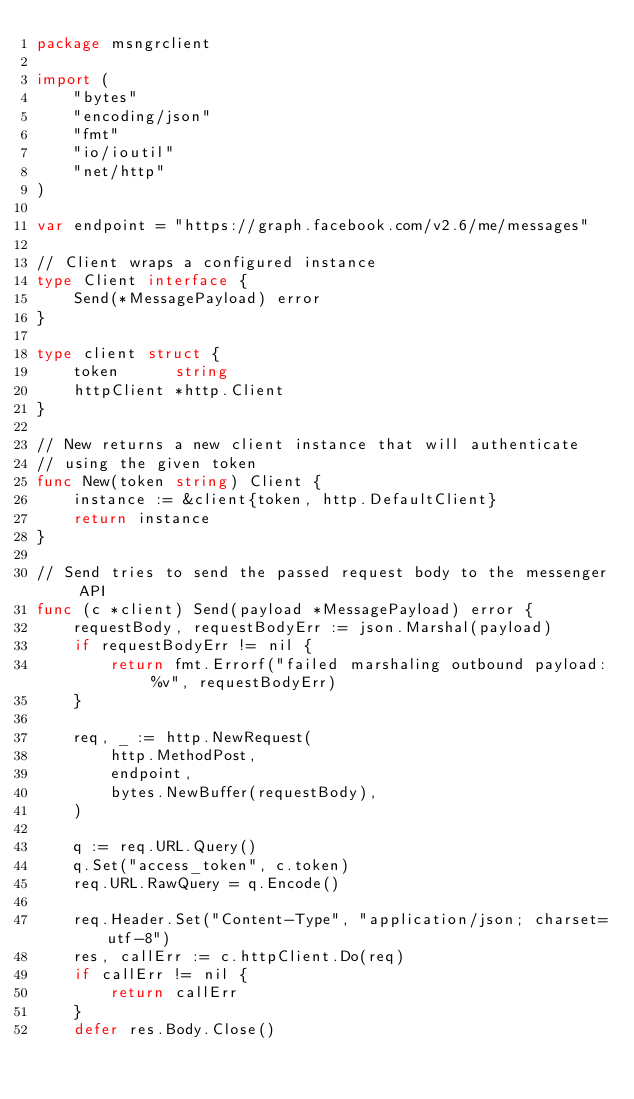<code> <loc_0><loc_0><loc_500><loc_500><_Go_>package msngrclient

import (
	"bytes"
	"encoding/json"
	"fmt"
	"io/ioutil"
	"net/http"
)

var endpoint = "https://graph.facebook.com/v2.6/me/messages"

// Client wraps a configured instance
type Client interface {
	Send(*MessagePayload) error
}

type client struct {
	token      string
	httpClient *http.Client
}

// New returns a new client instance that will authenticate
// using the given token
func New(token string) Client {
	instance := &client{token, http.DefaultClient}
	return instance
}

// Send tries to send the passed request body to the messenger API
func (c *client) Send(payload *MessagePayload) error {
	requestBody, requestBodyErr := json.Marshal(payload)
	if requestBodyErr != nil {
		return fmt.Errorf("failed marshaling outbound payload: %v", requestBodyErr)
	}

	req, _ := http.NewRequest(
		http.MethodPost,
		endpoint,
		bytes.NewBuffer(requestBody),
	)

	q := req.URL.Query()
	q.Set("access_token", c.token)
	req.URL.RawQuery = q.Encode()

	req.Header.Set("Content-Type", "application/json; charset=utf-8")
	res, callErr := c.httpClient.Do(req)
	if callErr != nil {
		return callErr
	}
	defer res.Body.Close()
</code> 